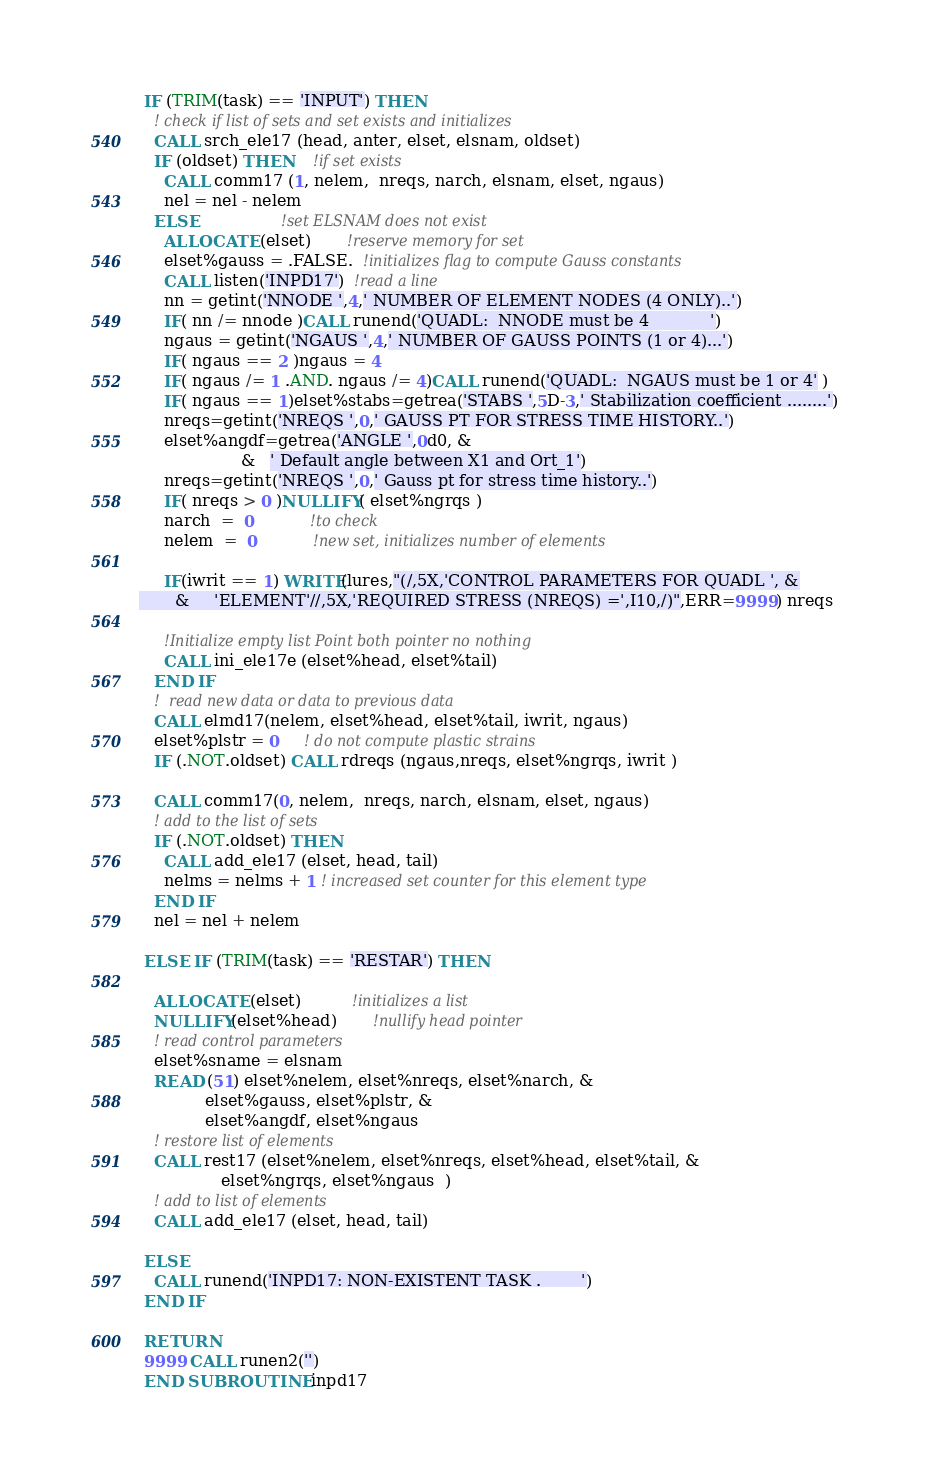<code> <loc_0><loc_0><loc_500><loc_500><_FORTRAN_>
 IF (TRIM(task) == 'INPUT') THEN
   ! check if list of sets and set exists and initializes
   CALL srch_ele17 (head, anter, elset, elsnam, oldset)
   IF (oldset) THEN    !if set exists
     CALL comm17 (1, nelem,  nreqs, narch, elsnam, elset, ngaus)
     nel = nel - nelem
   ELSE                !set ELSNAM does not exist
     ALLOCATE (elset)       !reserve memory for set
     elset%gauss = .FALSE.  !initializes flag to compute Gauss constants
     CALL listen('INPD17')  !read a line
     nn = getint('NNODE ',4,' NUMBER OF ELEMENT NODES (4 ONLY)..')
     IF( nn /= nnode )CALL runend('QUADL:  NNODE must be 4            ')
     ngaus = getint('NGAUS ',4,' NUMBER OF GAUSS POINTS (1 or 4)...')
     IF( ngaus == 2 )ngaus = 4
     IF( ngaus /= 1 .AND. ngaus /= 4)CALL runend('QUADL:  NGAUS must be 1 or 4' )
     IF( ngaus == 1)elset%stabs=getrea('STABS ',5D-3,' Stabilization coefficient ........')
     nreqs=getint('NREQS ',0,' GAUSS PT FOR STRESS TIME HISTORY..')
     elset%angdf=getrea('ANGLE ',0d0, &
                    &   ' Default angle between X1 and Ort_1')
     nreqs=getint('NREQS ',0,' Gauss pt for stress time history..')
     IF( nreqs > 0 )NULLIFY( elset%ngrqs )
     narch  =  0           !to check
     nelem  =  0           !new set, initializes number of elements

     IF(iwrit == 1) WRITE(lures,"(/,5X,'CONTROL PARAMETERS FOR QUADL ', &
       &     'ELEMENT'//,5X,'REQUIRED STRESS (NREQS) =',I10,/)",ERR=9999) nreqs

     !Initialize empty list Point both pointer no nothing
     CALL ini_ele17e (elset%head, elset%tail)
   END IF
   !  read new data or data to previous data
   CALL elmd17(nelem, elset%head, elset%tail, iwrit, ngaus)
   elset%plstr = 0     ! do not compute plastic strains
   IF (.NOT.oldset) CALL rdreqs (ngaus,nreqs, elset%ngrqs, iwrit )

   CALL comm17(0, nelem,  nreqs, narch, elsnam, elset, ngaus)
   ! add to the list of sets
   IF (.NOT.oldset) THEN
     CALL add_ele17 (elset, head, tail)
     nelms = nelms + 1 ! increased set counter for this element type
   END IF
   nel = nel + nelem

 ELSE IF (TRIM(task) == 'RESTAR') THEN

   ALLOCATE (elset)          !initializes a list
   NULLIFY(elset%head)       !nullify head pointer
   ! read control parameters
   elset%sname = elsnam
   READ (51) elset%nelem, elset%nreqs, elset%narch, &
             elset%gauss, elset%plstr, &
             elset%angdf, elset%ngaus
   ! restore list of elements
   CALL rest17 (elset%nelem, elset%nreqs, elset%head, elset%tail, &
                elset%ngrqs, elset%ngaus  )
   ! add to list of elements
   CALL add_ele17 (elset, head, tail)

 ELSE
   CALL runend('INPD17: NON-EXISTENT TASK .        ')
 END IF

 RETURN
 9999 CALL runen2('')
 END SUBROUTINE inpd17
</code> 